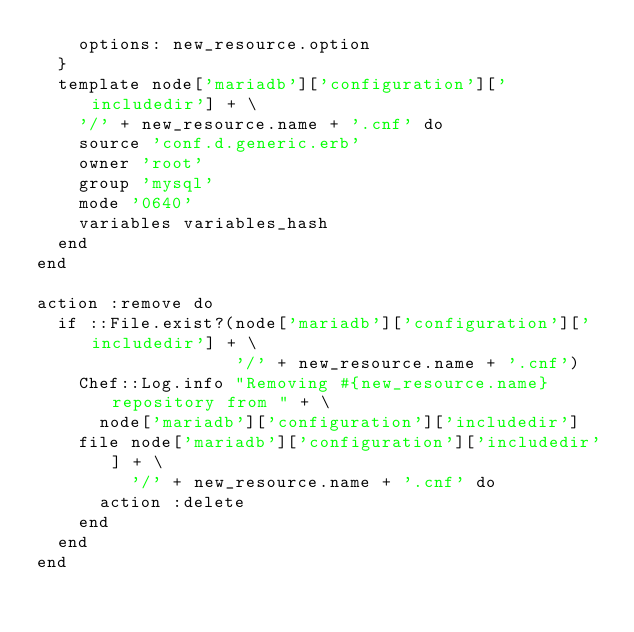<code> <loc_0><loc_0><loc_500><loc_500><_Ruby_>    options: new_resource.option
  }
  template node['mariadb']['configuration']['includedir'] + \
    '/' + new_resource.name + '.cnf' do
    source 'conf.d.generic.erb'
    owner 'root'
    group 'mysql'
    mode '0640'
    variables variables_hash
  end
end

action :remove do
  if ::File.exist?(node['mariadb']['configuration']['includedir'] + \
                   '/' + new_resource.name + '.cnf')
    Chef::Log.info "Removing #{new_resource.name} repository from " + \
      node['mariadb']['configuration']['includedir']
    file node['mariadb']['configuration']['includedir'] + \
         '/' + new_resource.name + '.cnf' do
      action :delete
    end
  end
end
</code> 